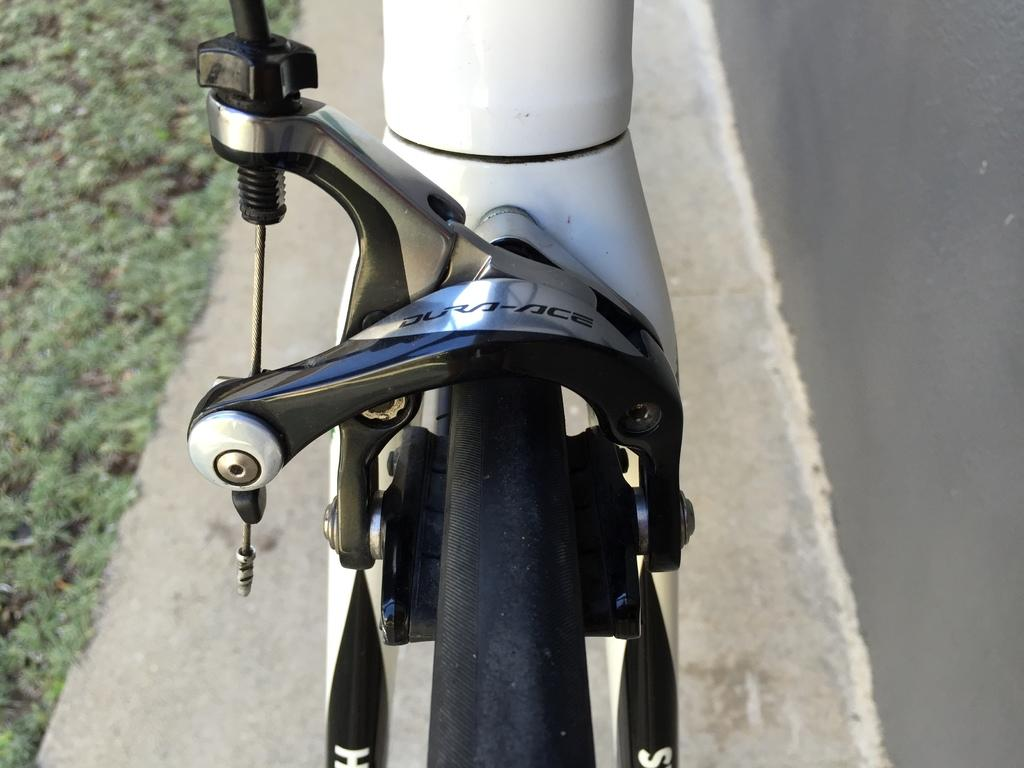What is the main subject in the center of the image? There is a vehicle in the center of the image. What can be seen in the background of the image? There is a road and ground visible in the background of the image. Where is the brother sleeping in the image? There is no brother or bed present in the image. What type of beam is holding up the ceiling in the image? There is no ceiling or beam present in the image. 